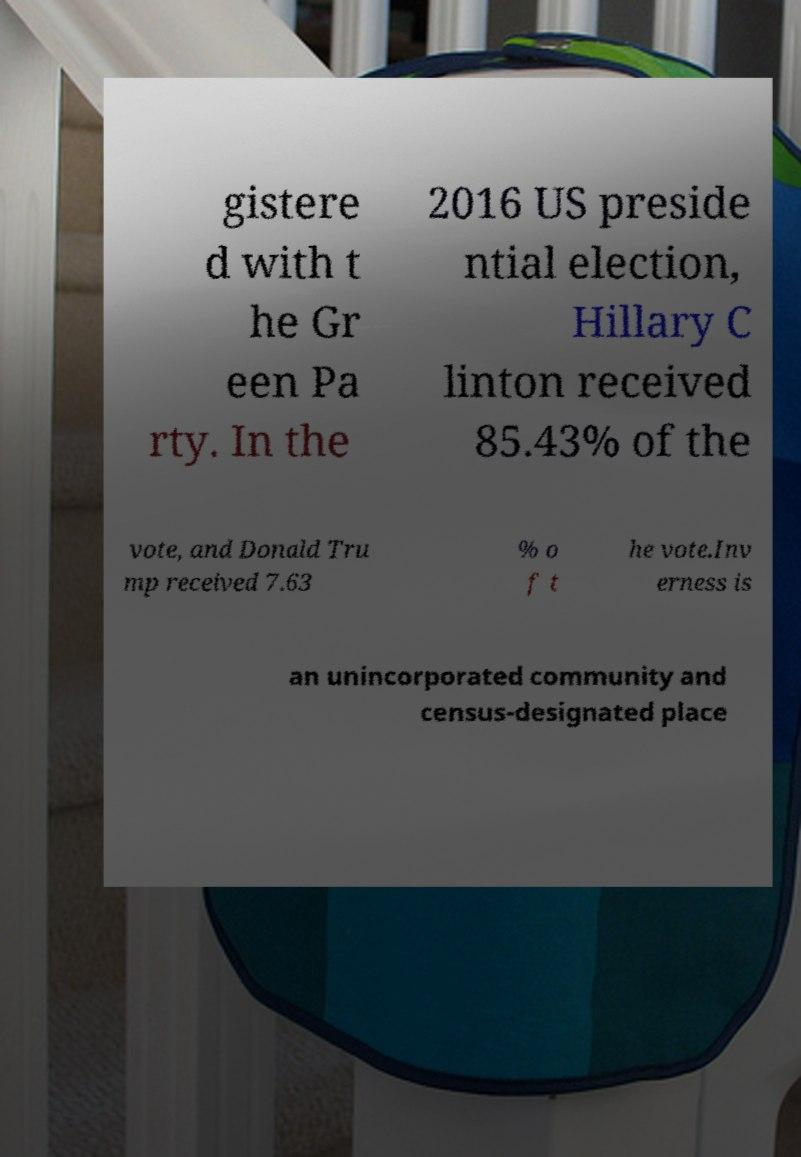Please read and relay the text visible in this image. What does it say? gistere d with t he Gr een Pa rty. In the 2016 US preside ntial election, Hillary C linton received 85.43% of the vote, and Donald Tru mp received 7.63 % o f t he vote.Inv erness is an unincorporated community and census-designated place 